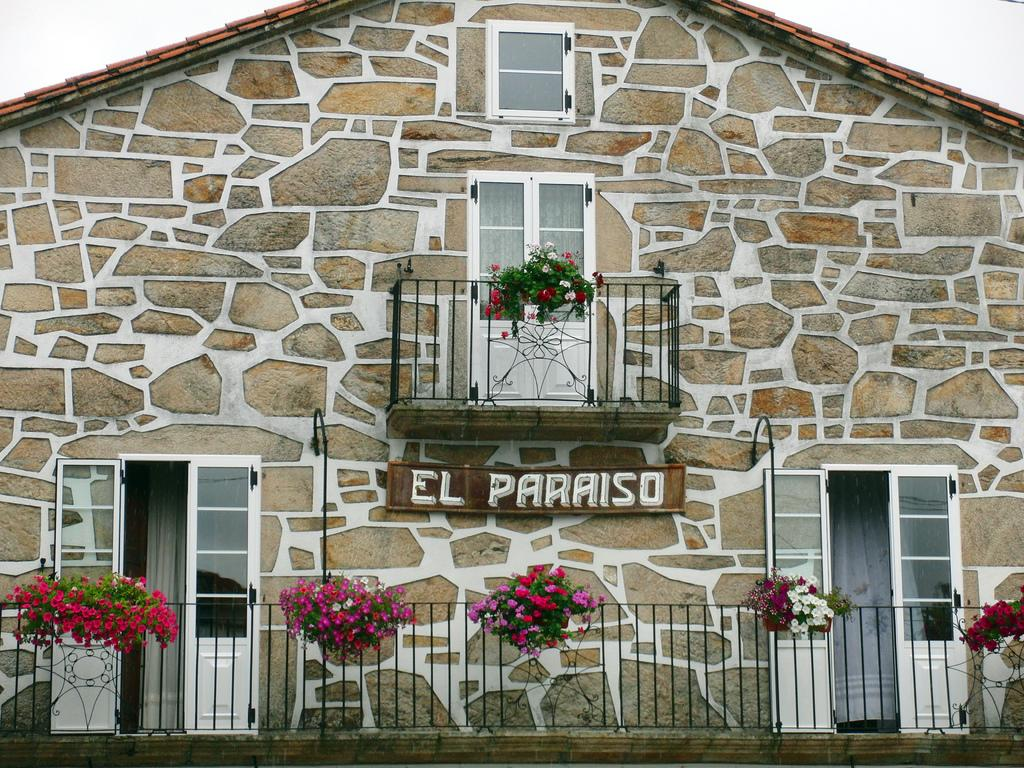What type of structure is visible in the image? There is a building in the image. What type of window treatment is present in the image? There are curtains in the image. What type of doors are visible in the image? There are glass doors in the image. What is written on the wooden board in the image? There is text on a wooden board in the image. What type of vegetation is present in the image? There are plants with flowers in the image. What learning attempt did the grandmother make in the image? There is no grandmother or learning attempt present in the image. 